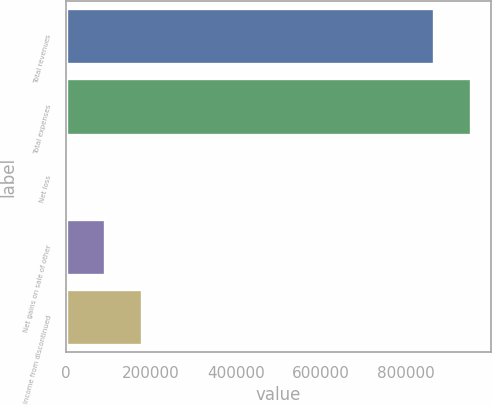<chart> <loc_0><loc_0><loc_500><loc_500><bar_chart><fcel>Total revenues<fcel>Total expenses<fcel>Net loss<fcel>Net gains on sale of other<fcel>Income from discontinued<nl><fcel>865584<fcel>952142<fcel>6592<fcel>93150.4<fcel>179709<nl></chart> 